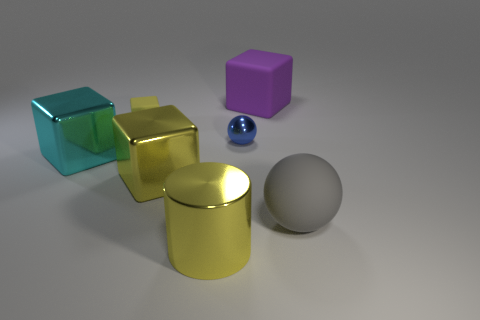Subtract all tiny yellow rubber blocks. How many blocks are left? 3 Add 2 tiny metal things. How many objects exist? 9 Subtract all green spheres. How many yellow cubes are left? 2 Subtract all purple cubes. How many cubes are left? 3 Subtract 2 blocks. How many blocks are left? 2 Subtract all gray blocks. Subtract all gray balls. How many blocks are left? 4 Subtract all large matte objects. Subtract all tiny purple cylinders. How many objects are left? 5 Add 1 large gray things. How many large gray things are left? 2 Add 3 purple rubber cubes. How many purple rubber cubes exist? 4 Subtract 1 cyan blocks. How many objects are left? 6 